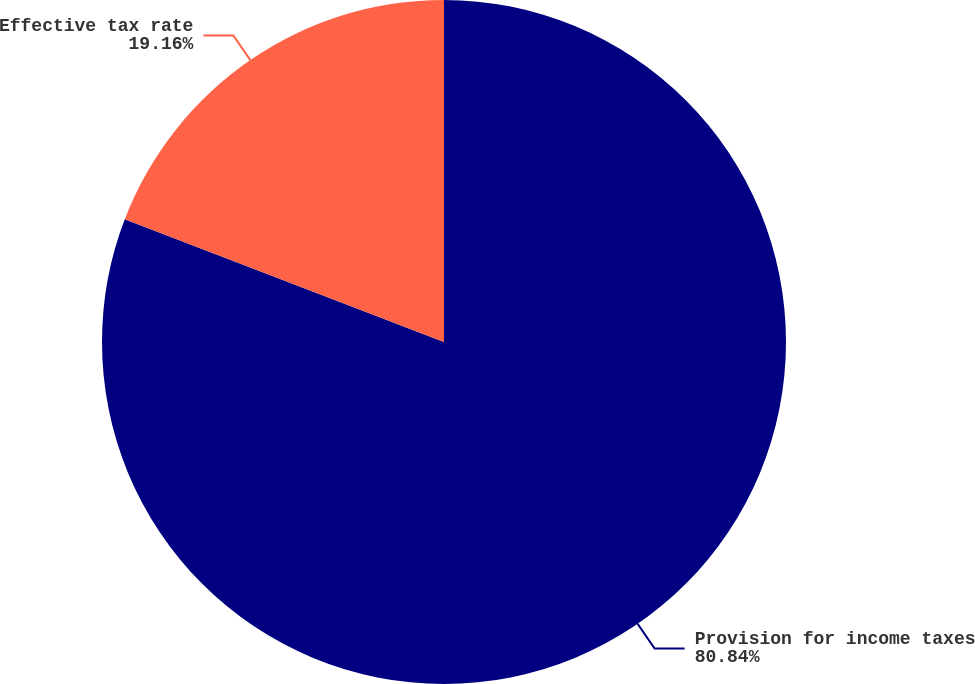Convert chart. <chart><loc_0><loc_0><loc_500><loc_500><pie_chart><fcel>Provision for income taxes<fcel>Effective tax rate<nl><fcel>80.84%<fcel>19.16%<nl></chart> 